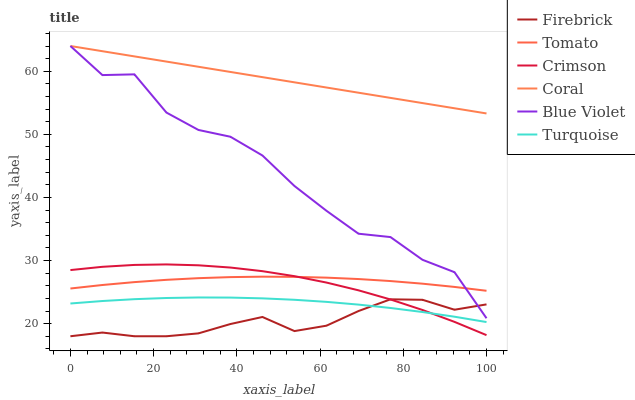Does Firebrick have the minimum area under the curve?
Answer yes or no. Yes. Does Coral have the maximum area under the curve?
Answer yes or no. Yes. Does Turquoise have the minimum area under the curve?
Answer yes or no. No. Does Turquoise have the maximum area under the curve?
Answer yes or no. No. Is Coral the smoothest?
Answer yes or no. Yes. Is Blue Violet the roughest?
Answer yes or no. Yes. Is Turquoise the smoothest?
Answer yes or no. No. Is Turquoise the roughest?
Answer yes or no. No. Does Turquoise have the lowest value?
Answer yes or no. No. Does Turquoise have the highest value?
Answer yes or no. No. Is Crimson less than Coral?
Answer yes or no. Yes. Is Blue Violet greater than Turquoise?
Answer yes or no. Yes. Does Crimson intersect Coral?
Answer yes or no. No. 